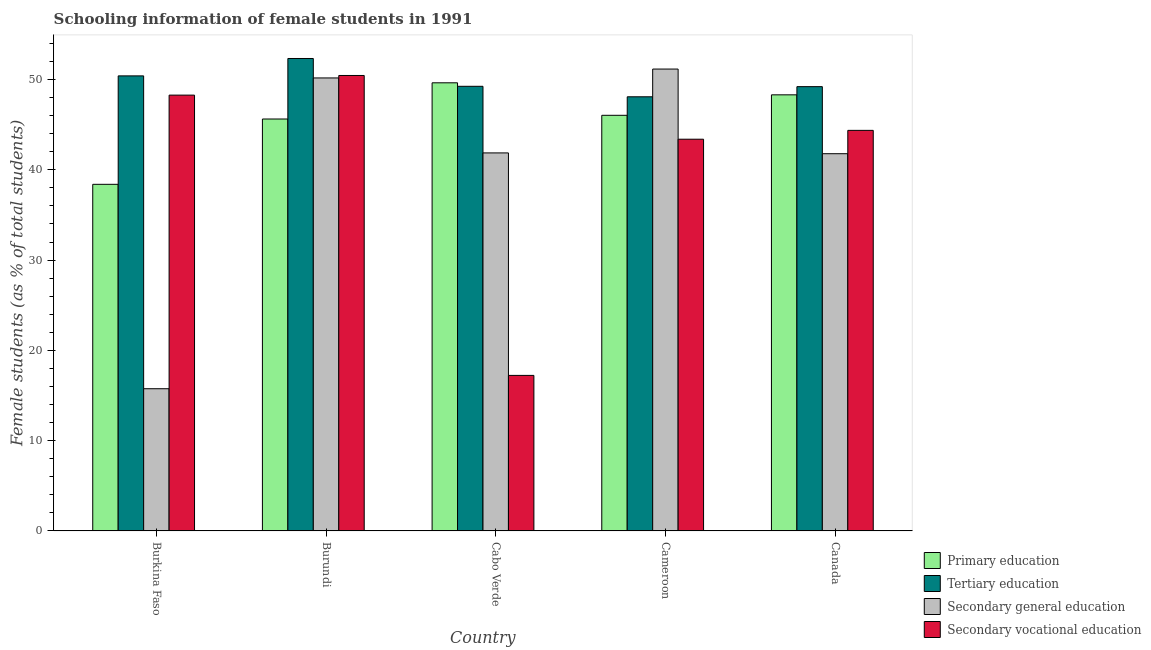How many bars are there on the 4th tick from the right?
Your answer should be very brief. 4. What is the label of the 1st group of bars from the left?
Keep it short and to the point. Burkina Faso. In how many cases, is the number of bars for a given country not equal to the number of legend labels?
Your response must be concise. 0. What is the percentage of female students in primary education in Cabo Verde?
Offer a very short reply. 49.63. Across all countries, what is the maximum percentage of female students in secondary education?
Make the answer very short. 51.16. Across all countries, what is the minimum percentage of female students in secondary vocational education?
Provide a succinct answer. 17.23. In which country was the percentage of female students in tertiary education maximum?
Provide a short and direct response. Burundi. In which country was the percentage of female students in tertiary education minimum?
Offer a very short reply. Cameroon. What is the total percentage of female students in secondary education in the graph?
Your answer should be compact. 200.73. What is the difference between the percentage of female students in secondary vocational education in Burundi and that in Cabo Verde?
Keep it short and to the point. 33.22. What is the difference between the percentage of female students in secondary education in Burundi and the percentage of female students in secondary vocational education in Cabo Verde?
Offer a terse response. 32.94. What is the average percentage of female students in tertiary education per country?
Offer a very short reply. 49.85. What is the difference between the percentage of female students in secondary education and percentage of female students in tertiary education in Burkina Faso?
Your answer should be compact. -34.65. In how many countries, is the percentage of female students in secondary education greater than 10 %?
Offer a very short reply. 5. What is the ratio of the percentage of female students in primary education in Burkina Faso to that in Canada?
Your answer should be very brief. 0.79. Is the percentage of female students in secondary education in Burkina Faso less than that in Canada?
Your answer should be compact. Yes. What is the difference between the highest and the second highest percentage of female students in secondary education?
Give a very brief answer. 0.98. What is the difference between the highest and the lowest percentage of female students in secondary education?
Your response must be concise. 35.41. Is the sum of the percentage of female students in secondary vocational education in Burkina Faso and Cameroon greater than the maximum percentage of female students in secondary education across all countries?
Your answer should be compact. Yes. What does the 4th bar from the left in Cabo Verde represents?
Give a very brief answer. Secondary vocational education. Is it the case that in every country, the sum of the percentage of female students in primary education and percentage of female students in tertiary education is greater than the percentage of female students in secondary education?
Provide a short and direct response. Yes. How many countries are there in the graph?
Your response must be concise. 5. What is the difference between two consecutive major ticks on the Y-axis?
Provide a short and direct response. 10. Are the values on the major ticks of Y-axis written in scientific E-notation?
Your answer should be compact. No. Does the graph contain grids?
Offer a terse response. No. Where does the legend appear in the graph?
Ensure brevity in your answer.  Bottom right. How are the legend labels stacked?
Your answer should be compact. Vertical. What is the title of the graph?
Give a very brief answer. Schooling information of female students in 1991. What is the label or title of the Y-axis?
Your response must be concise. Female students (as % of total students). What is the Female students (as % of total students) in Primary education in Burkina Faso?
Your answer should be compact. 38.39. What is the Female students (as % of total students) of Tertiary education in Burkina Faso?
Keep it short and to the point. 50.4. What is the Female students (as % of total students) of Secondary general education in Burkina Faso?
Provide a succinct answer. 15.75. What is the Female students (as % of total students) in Secondary vocational education in Burkina Faso?
Make the answer very short. 48.27. What is the Female students (as % of total students) of Primary education in Burundi?
Keep it short and to the point. 45.62. What is the Female students (as % of total students) in Tertiary education in Burundi?
Offer a terse response. 52.33. What is the Female students (as % of total students) in Secondary general education in Burundi?
Provide a short and direct response. 50.17. What is the Female students (as % of total students) in Secondary vocational education in Burundi?
Give a very brief answer. 50.45. What is the Female students (as % of total students) in Primary education in Cabo Verde?
Your answer should be very brief. 49.63. What is the Female students (as % of total students) in Tertiary education in Cabo Verde?
Make the answer very short. 49.25. What is the Female students (as % of total students) of Secondary general education in Cabo Verde?
Provide a succinct answer. 41.87. What is the Female students (as % of total students) of Secondary vocational education in Cabo Verde?
Offer a very short reply. 17.23. What is the Female students (as % of total students) in Primary education in Cameroon?
Your answer should be compact. 46.03. What is the Female students (as % of total students) in Tertiary education in Cameroon?
Provide a succinct answer. 48.09. What is the Female students (as % of total students) of Secondary general education in Cameroon?
Give a very brief answer. 51.16. What is the Female students (as % of total students) of Secondary vocational education in Cameroon?
Make the answer very short. 43.39. What is the Female students (as % of total students) of Primary education in Canada?
Make the answer very short. 48.3. What is the Female students (as % of total students) in Tertiary education in Canada?
Make the answer very short. 49.21. What is the Female students (as % of total students) in Secondary general education in Canada?
Keep it short and to the point. 41.78. What is the Female students (as % of total students) of Secondary vocational education in Canada?
Provide a short and direct response. 44.37. Across all countries, what is the maximum Female students (as % of total students) of Primary education?
Provide a succinct answer. 49.63. Across all countries, what is the maximum Female students (as % of total students) of Tertiary education?
Make the answer very short. 52.33. Across all countries, what is the maximum Female students (as % of total students) in Secondary general education?
Keep it short and to the point. 51.16. Across all countries, what is the maximum Female students (as % of total students) of Secondary vocational education?
Make the answer very short. 50.45. Across all countries, what is the minimum Female students (as % of total students) in Primary education?
Provide a short and direct response. 38.39. Across all countries, what is the minimum Female students (as % of total students) of Tertiary education?
Your response must be concise. 48.09. Across all countries, what is the minimum Female students (as % of total students) in Secondary general education?
Your response must be concise. 15.75. Across all countries, what is the minimum Female students (as % of total students) of Secondary vocational education?
Give a very brief answer. 17.23. What is the total Female students (as % of total students) in Primary education in the graph?
Your answer should be compact. 227.99. What is the total Female students (as % of total students) in Tertiary education in the graph?
Your response must be concise. 249.27. What is the total Female students (as % of total students) in Secondary general education in the graph?
Offer a terse response. 200.73. What is the total Female students (as % of total students) in Secondary vocational education in the graph?
Ensure brevity in your answer.  203.7. What is the difference between the Female students (as % of total students) in Primary education in Burkina Faso and that in Burundi?
Your response must be concise. -7.23. What is the difference between the Female students (as % of total students) in Tertiary education in Burkina Faso and that in Burundi?
Your answer should be compact. -1.93. What is the difference between the Female students (as % of total students) in Secondary general education in Burkina Faso and that in Burundi?
Your response must be concise. -34.42. What is the difference between the Female students (as % of total students) of Secondary vocational education in Burkina Faso and that in Burundi?
Ensure brevity in your answer.  -2.18. What is the difference between the Female students (as % of total students) of Primary education in Burkina Faso and that in Cabo Verde?
Your response must be concise. -11.24. What is the difference between the Female students (as % of total students) of Tertiary education in Burkina Faso and that in Cabo Verde?
Provide a short and direct response. 1.15. What is the difference between the Female students (as % of total students) of Secondary general education in Burkina Faso and that in Cabo Verde?
Offer a terse response. -26.12. What is the difference between the Female students (as % of total students) in Secondary vocational education in Burkina Faso and that in Cabo Verde?
Your response must be concise. 31.04. What is the difference between the Female students (as % of total students) of Primary education in Burkina Faso and that in Cameroon?
Give a very brief answer. -7.64. What is the difference between the Female students (as % of total students) of Tertiary education in Burkina Faso and that in Cameroon?
Offer a terse response. 2.32. What is the difference between the Female students (as % of total students) in Secondary general education in Burkina Faso and that in Cameroon?
Your response must be concise. -35.41. What is the difference between the Female students (as % of total students) in Secondary vocational education in Burkina Faso and that in Cameroon?
Give a very brief answer. 4.88. What is the difference between the Female students (as % of total students) of Primary education in Burkina Faso and that in Canada?
Give a very brief answer. -9.91. What is the difference between the Female students (as % of total students) of Tertiary education in Burkina Faso and that in Canada?
Offer a terse response. 1.19. What is the difference between the Female students (as % of total students) of Secondary general education in Burkina Faso and that in Canada?
Your answer should be compact. -26.03. What is the difference between the Female students (as % of total students) of Secondary vocational education in Burkina Faso and that in Canada?
Offer a very short reply. 3.9. What is the difference between the Female students (as % of total students) in Primary education in Burundi and that in Cabo Verde?
Keep it short and to the point. -4.01. What is the difference between the Female students (as % of total students) of Tertiary education in Burundi and that in Cabo Verde?
Provide a short and direct response. 3.08. What is the difference between the Female students (as % of total students) of Secondary general education in Burundi and that in Cabo Verde?
Ensure brevity in your answer.  8.3. What is the difference between the Female students (as % of total students) of Secondary vocational education in Burundi and that in Cabo Verde?
Ensure brevity in your answer.  33.22. What is the difference between the Female students (as % of total students) of Primary education in Burundi and that in Cameroon?
Give a very brief answer. -0.41. What is the difference between the Female students (as % of total students) in Tertiary education in Burundi and that in Cameroon?
Give a very brief answer. 4.24. What is the difference between the Female students (as % of total students) in Secondary general education in Burundi and that in Cameroon?
Provide a succinct answer. -0.98. What is the difference between the Female students (as % of total students) of Secondary vocational education in Burundi and that in Cameroon?
Offer a very short reply. 7.06. What is the difference between the Female students (as % of total students) in Primary education in Burundi and that in Canada?
Offer a very short reply. -2.68. What is the difference between the Female students (as % of total students) in Tertiary education in Burundi and that in Canada?
Your answer should be compact. 3.12. What is the difference between the Female students (as % of total students) of Secondary general education in Burundi and that in Canada?
Your answer should be very brief. 8.39. What is the difference between the Female students (as % of total students) of Secondary vocational education in Burundi and that in Canada?
Give a very brief answer. 6.08. What is the difference between the Female students (as % of total students) in Primary education in Cabo Verde and that in Cameroon?
Your answer should be very brief. 3.6. What is the difference between the Female students (as % of total students) of Tertiary education in Cabo Verde and that in Cameroon?
Your answer should be very brief. 1.16. What is the difference between the Female students (as % of total students) of Secondary general education in Cabo Verde and that in Cameroon?
Provide a short and direct response. -9.29. What is the difference between the Female students (as % of total students) in Secondary vocational education in Cabo Verde and that in Cameroon?
Your response must be concise. -26.16. What is the difference between the Female students (as % of total students) in Primary education in Cabo Verde and that in Canada?
Offer a terse response. 1.33. What is the difference between the Female students (as % of total students) in Tertiary education in Cabo Verde and that in Canada?
Your answer should be very brief. 0.04. What is the difference between the Female students (as % of total students) in Secondary general education in Cabo Verde and that in Canada?
Offer a terse response. 0.09. What is the difference between the Female students (as % of total students) of Secondary vocational education in Cabo Verde and that in Canada?
Offer a very short reply. -27.14. What is the difference between the Female students (as % of total students) in Primary education in Cameroon and that in Canada?
Provide a short and direct response. -2.27. What is the difference between the Female students (as % of total students) in Tertiary education in Cameroon and that in Canada?
Offer a terse response. -1.12. What is the difference between the Female students (as % of total students) of Secondary general education in Cameroon and that in Canada?
Provide a succinct answer. 9.38. What is the difference between the Female students (as % of total students) in Secondary vocational education in Cameroon and that in Canada?
Your response must be concise. -0.98. What is the difference between the Female students (as % of total students) in Primary education in Burkina Faso and the Female students (as % of total students) in Tertiary education in Burundi?
Your answer should be compact. -13.94. What is the difference between the Female students (as % of total students) of Primary education in Burkina Faso and the Female students (as % of total students) of Secondary general education in Burundi?
Your answer should be compact. -11.78. What is the difference between the Female students (as % of total students) of Primary education in Burkina Faso and the Female students (as % of total students) of Secondary vocational education in Burundi?
Your answer should be compact. -12.05. What is the difference between the Female students (as % of total students) of Tertiary education in Burkina Faso and the Female students (as % of total students) of Secondary general education in Burundi?
Offer a very short reply. 0.23. What is the difference between the Female students (as % of total students) in Tertiary education in Burkina Faso and the Female students (as % of total students) in Secondary vocational education in Burundi?
Give a very brief answer. -0.04. What is the difference between the Female students (as % of total students) of Secondary general education in Burkina Faso and the Female students (as % of total students) of Secondary vocational education in Burundi?
Your response must be concise. -34.7. What is the difference between the Female students (as % of total students) in Primary education in Burkina Faso and the Female students (as % of total students) in Tertiary education in Cabo Verde?
Your response must be concise. -10.86. What is the difference between the Female students (as % of total students) of Primary education in Burkina Faso and the Female students (as % of total students) of Secondary general education in Cabo Verde?
Your response must be concise. -3.48. What is the difference between the Female students (as % of total students) in Primary education in Burkina Faso and the Female students (as % of total students) in Secondary vocational education in Cabo Verde?
Ensure brevity in your answer.  21.16. What is the difference between the Female students (as % of total students) in Tertiary education in Burkina Faso and the Female students (as % of total students) in Secondary general education in Cabo Verde?
Give a very brief answer. 8.53. What is the difference between the Female students (as % of total students) in Tertiary education in Burkina Faso and the Female students (as % of total students) in Secondary vocational education in Cabo Verde?
Provide a succinct answer. 33.17. What is the difference between the Female students (as % of total students) of Secondary general education in Burkina Faso and the Female students (as % of total students) of Secondary vocational education in Cabo Verde?
Your answer should be very brief. -1.48. What is the difference between the Female students (as % of total students) in Primary education in Burkina Faso and the Female students (as % of total students) in Tertiary education in Cameroon?
Your response must be concise. -9.69. What is the difference between the Female students (as % of total students) of Primary education in Burkina Faso and the Female students (as % of total students) of Secondary general education in Cameroon?
Your answer should be very brief. -12.76. What is the difference between the Female students (as % of total students) in Primary education in Burkina Faso and the Female students (as % of total students) in Secondary vocational education in Cameroon?
Offer a very short reply. -5. What is the difference between the Female students (as % of total students) of Tertiary education in Burkina Faso and the Female students (as % of total students) of Secondary general education in Cameroon?
Keep it short and to the point. -0.76. What is the difference between the Female students (as % of total students) in Tertiary education in Burkina Faso and the Female students (as % of total students) in Secondary vocational education in Cameroon?
Keep it short and to the point. 7.01. What is the difference between the Female students (as % of total students) in Secondary general education in Burkina Faso and the Female students (as % of total students) in Secondary vocational education in Cameroon?
Offer a very short reply. -27.64. What is the difference between the Female students (as % of total students) of Primary education in Burkina Faso and the Female students (as % of total students) of Tertiary education in Canada?
Your answer should be compact. -10.82. What is the difference between the Female students (as % of total students) in Primary education in Burkina Faso and the Female students (as % of total students) in Secondary general education in Canada?
Your answer should be very brief. -3.39. What is the difference between the Female students (as % of total students) of Primary education in Burkina Faso and the Female students (as % of total students) of Secondary vocational education in Canada?
Ensure brevity in your answer.  -5.97. What is the difference between the Female students (as % of total students) in Tertiary education in Burkina Faso and the Female students (as % of total students) in Secondary general education in Canada?
Your answer should be very brief. 8.62. What is the difference between the Female students (as % of total students) of Tertiary education in Burkina Faso and the Female students (as % of total students) of Secondary vocational education in Canada?
Ensure brevity in your answer.  6.04. What is the difference between the Female students (as % of total students) in Secondary general education in Burkina Faso and the Female students (as % of total students) in Secondary vocational education in Canada?
Your answer should be very brief. -28.62. What is the difference between the Female students (as % of total students) in Primary education in Burundi and the Female students (as % of total students) in Tertiary education in Cabo Verde?
Make the answer very short. -3.62. What is the difference between the Female students (as % of total students) in Primary education in Burundi and the Female students (as % of total students) in Secondary general education in Cabo Verde?
Give a very brief answer. 3.76. What is the difference between the Female students (as % of total students) of Primary education in Burundi and the Female students (as % of total students) of Secondary vocational education in Cabo Verde?
Your response must be concise. 28.4. What is the difference between the Female students (as % of total students) in Tertiary education in Burundi and the Female students (as % of total students) in Secondary general education in Cabo Verde?
Your answer should be compact. 10.46. What is the difference between the Female students (as % of total students) of Tertiary education in Burundi and the Female students (as % of total students) of Secondary vocational education in Cabo Verde?
Your response must be concise. 35.1. What is the difference between the Female students (as % of total students) in Secondary general education in Burundi and the Female students (as % of total students) in Secondary vocational education in Cabo Verde?
Offer a terse response. 32.95. What is the difference between the Female students (as % of total students) of Primary education in Burundi and the Female students (as % of total students) of Tertiary education in Cameroon?
Your answer should be very brief. -2.46. What is the difference between the Female students (as % of total students) of Primary education in Burundi and the Female students (as % of total students) of Secondary general education in Cameroon?
Your answer should be compact. -5.53. What is the difference between the Female students (as % of total students) of Primary education in Burundi and the Female students (as % of total students) of Secondary vocational education in Cameroon?
Provide a short and direct response. 2.24. What is the difference between the Female students (as % of total students) of Tertiary education in Burundi and the Female students (as % of total students) of Secondary general education in Cameroon?
Provide a short and direct response. 1.17. What is the difference between the Female students (as % of total students) of Tertiary education in Burundi and the Female students (as % of total students) of Secondary vocational education in Cameroon?
Provide a short and direct response. 8.94. What is the difference between the Female students (as % of total students) in Secondary general education in Burundi and the Female students (as % of total students) in Secondary vocational education in Cameroon?
Provide a succinct answer. 6.79. What is the difference between the Female students (as % of total students) in Primary education in Burundi and the Female students (as % of total students) in Tertiary education in Canada?
Your answer should be compact. -3.58. What is the difference between the Female students (as % of total students) in Primary education in Burundi and the Female students (as % of total students) in Secondary general education in Canada?
Ensure brevity in your answer.  3.84. What is the difference between the Female students (as % of total students) in Primary education in Burundi and the Female students (as % of total students) in Secondary vocational education in Canada?
Offer a very short reply. 1.26. What is the difference between the Female students (as % of total students) of Tertiary education in Burundi and the Female students (as % of total students) of Secondary general education in Canada?
Keep it short and to the point. 10.55. What is the difference between the Female students (as % of total students) of Tertiary education in Burundi and the Female students (as % of total students) of Secondary vocational education in Canada?
Make the answer very short. 7.96. What is the difference between the Female students (as % of total students) of Secondary general education in Burundi and the Female students (as % of total students) of Secondary vocational education in Canada?
Your answer should be compact. 5.81. What is the difference between the Female students (as % of total students) of Primary education in Cabo Verde and the Female students (as % of total students) of Tertiary education in Cameroon?
Give a very brief answer. 1.55. What is the difference between the Female students (as % of total students) in Primary education in Cabo Verde and the Female students (as % of total students) in Secondary general education in Cameroon?
Your answer should be compact. -1.52. What is the difference between the Female students (as % of total students) of Primary education in Cabo Verde and the Female students (as % of total students) of Secondary vocational education in Cameroon?
Ensure brevity in your answer.  6.25. What is the difference between the Female students (as % of total students) in Tertiary education in Cabo Verde and the Female students (as % of total students) in Secondary general education in Cameroon?
Offer a very short reply. -1.91. What is the difference between the Female students (as % of total students) of Tertiary education in Cabo Verde and the Female students (as % of total students) of Secondary vocational education in Cameroon?
Offer a very short reply. 5.86. What is the difference between the Female students (as % of total students) in Secondary general education in Cabo Verde and the Female students (as % of total students) in Secondary vocational education in Cameroon?
Offer a terse response. -1.52. What is the difference between the Female students (as % of total students) in Primary education in Cabo Verde and the Female students (as % of total students) in Tertiary education in Canada?
Offer a very short reply. 0.43. What is the difference between the Female students (as % of total students) in Primary education in Cabo Verde and the Female students (as % of total students) in Secondary general education in Canada?
Your answer should be compact. 7.85. What is the difference between the Female students (as % of total students) in Primary education in Cabo Verde and the Female students (as % of total students) in Secondary vocational education in Canada?
Your response must be concise. 5.27. What is the difference between the Female students (as % of total students) of Tertiary education in Cabo Verde and the Female students (as % of total students) of Secondary general education in Canada?
Your answer should be very brief. 7.47. What is the difference between the Female students (as % of total students) of Tertiary education in Cabo Verde and the Female students (as % of total students) of Secondary vocational education in Canada?
Your answer should be very brief. 4.88. What is the difference between the Female students (as % of total students) in Secondary general education in Cabo Verde and the Female students (as % of total students) in Secondary vocational education in Canada?
Your answer should be very brief. -2.5. What is the difference between the Female students (as % of total students) of Primary education in Cameroon and the Female students (as % of total students) of Tertiary education in Canada?
Your response must be concise. -3.17. What is the difference between the Female students (as % of total students) of Primary education in Cameroon and the Female students (as % of total students) of Secondary general education in Canada?
Your answer should be compact. 4.25. What is the difference between the Female students (as % of total students) in Primary education in Cameroon and the Female students (as % of total students) in Secondary vocational education in Canada?
Your answer should be very brief. 1.67. What is the difference between the Female students (as % of total students) in Tertiary education in Cameroon and the Female students (as % of total students) in Secondary general education in Canada?
Give a very brief answer. 6.3. What is the difference between the Female students (as % of total students) of Tertiary education in Cameroon and the Female students (as % of total students) of Secondary vocational education in Canada?
Keep it short and to the point. 3.72. What is the difference between the Female students (as % of total students) in Secondary general education in Cameroon and the Female students (as % of total students) in Secondary vocational education in Canada?
Ensure brevity in your answer.  6.79. What is the average Female students (as % of total students) of Primary education per country?
Keep it short and to the point. 45.6. What is the average Female students (as % of total students) in Tertiary education per country?
Make the answer very short. 49.85. What is the average Female students (as % of total students) of Secondary general education per country?
Offer a very short reply. 40.15. What is the average Female students (as % of total students) of Secondary vocational education per country?
Make the answer very short. 40.74. What is the difference between the Female students (as % of total students) in Primary education and Female students (as % of total students) in Tertiary education in Burkina Faso?
Your response must be concise. -12.01. What is the difference between the Female students (as % of total students) of Primary education and Female students (as % of total students) of Secondary general education in Burkina Faso?
Keep it short and to the point. 22.64. What is the difference between the Female students (as % of total students) of Primary education and Female students (as % of total students) of Secondary vocational education in Burkina Faso?
Ensure brevity in your answer.  -9.88. What is the difference between the Female students (as % of total students) in Tertiary education and Female students (as % of total students) in Secondary general education in Burkina Faso?
Offer a terse response. 34.65. What is the difference between the Female students (as % of total students) in Tertiary education and Female students (as % of total students) in Secondary vocational education in Burkina Faso?
Your answer should be compact. 2.13. What is the difference between the Female students (as % of total students) of Secondary general education and Female students (as % of total students) of Secondary vocational education in Burkina Faso?
Ensure brevity in your answer.  -32.52. What is the difference between the Female students (as % of total students) of Primary education and Female students (as % of total students) of Tertiary education in Burundi?
Your answer should be compact. -6.7. What is the difference between the Female students (as % of total students) in Primary education and Female students (as % of total students) in Secondary general education in Burundi?
Provide a short and direct response. -4.55. What is the difference between the Female students (as % of total students) in Primary education and Female students (as % of total students) in Secondary vocational education in Burundi?
Make the answer very short. -4.82. What is the difference between the Female students (as % of total students) of Tertiary education and Female students (as % of total students) of Secondary general education in Burundi?
Ensure brevity in your answer.  2.15. What is the difference between the Female students (as % of total students) in Tertiary education and Female students (as % of total students) in Secondary vocational education in Burundi?
Make the answer very short. 1.88. What is the difference between the Female students (as % of total students) of Secondary general education and Female students (as % of total students) of Secondary vocational education in Burundi?
Make the answer very short. -0.27. What is the difference between the Female students (as % of total students) in Primary education and Female students (as % of total students) in Tertiary education in Cabo Verde?
Provide a short and direct response. 0.39. What is the difference between the Female students (as % of total students) in Primary education and Female students (as % of total students) in Secondary general education in Cabo Verde?
Give a very brief answer. 7.76. What is the difference between the Female students (as % of total students) in Primary education and Female students (as % of total students) in Secondary vocational education in Cabo Verde?
Provide a short and direct response. 32.41. What is the difference between the Female students (as % of total students) in Tertiary education and Female students (as % of total students) in Secondary general education in Cabo Verde?
Ensure brevity in your answer.  7.38. What is the difference between the Female students (as % of total students) of Tertiary education and Female students (as % of total students) of Secondary vocational education in Cabo Verde?
Offer a very short reply. 32.02. What is the difference between the Female students (as % of total students) in Secondary general education and Female students (as % of total students) in Secondary vocational education in Cabo Verde?
Ensure brevity in your answer.  24.64. What is the difference between the Female students (as % of total students) in Primary education and Female students (as % of total students) in Tertiary education in Cameroon?
Provide a short and direct response. -2.05. What is the difference between the Female students (as % of total students) in Primary education and Female students (as % of total students) in Secondary general education in Cameroon?
Your response must be concise. -5.12. What is the difference between the Female students (as % of total students) in Primary education and Female students (as % of total students) in Secondary vocational education in Cameroon?
Provide a succinct answer. 2.65. What is the difference between the Female students (as % of total students) in Tertiary education and Female students (as % of total students) in Secondary general education in Cameroon?
Ensure brevity in your answer.  -3.07. What is the difference between the Female students (as % of total students) in Tertiary education and Female students (as % of total students) in Secondary vocational education in Cameroon?
Offer a terse response. 4.7. What is the difference between the Female students (as % of total students) of Secondary general education and Female students (as % of total students) of Secondary vocational education in Cameroon?
Offer a terse response. 7.77. What is the difference between the Female students (as % of total students) of Primary education and Female students (as % of total students) of Tertiary education in Canada?
Provide a succinct answer. -0.91. What is the difference between the Female students (as % of total students) in Primary education and Female students (as % of total students) in Secondary general education in Canada?
Keep it short and to the point. 6.52. What is the difference between the Female students (as % of total students) in Primary education and Female students (as % of total students) in Secondary vocational education in Canada?
Provide a succinct answer. 3.94. What is the difference between the Female students (as % of total students) in Tertiary education and Female students (as % of total students) in Secondary general education in Canada?
Your answer should be very brief. 7.43. What is the difference between the Female students (as % of total students) of Tertiary education and Female students (as % of total students) of Secondary vocational education in Canada?
Offer a very short reply. 4.84. What is the difference between the Female students (as % of total students) of Secondary general education and Female students (as % of total students) of Secondary vocational education in Canada?
Offer a very short reply. -2.58. What is the ratio of the Female students (as % of total students) of Primary education in Burkina Faso to that in Burundi?
Provide a succinct answer. 0.84. What is the ratio of the Female students (as % of total students) of Tertiary education in Burkina Faso to that in Burundi?
Make the answer very short. 0.96. What is the ratio of the Female students (as % of total students) in Secondary general education in Burkina Faso to that in Burundi?
Make the answer very short. 0.31. What is the ratio of the Female students (as % of total students) of Secondary vocational education in Burkina Faso to that in Burundi?
Provide a succinct answer. 0.96. What is the ratio of the Female students (as % of total students) of Primary education in Burkina Faso to that in Cabo Verde?
Give a very brief answer. 0.77. What is the ratio of the Female students (as % of total students) in Tertiary education in Burkina Faso to that in Cabo Verde?
Your response must be concise. 1.02. What is the ratio of the Female students (as % of total students) of Secondary general education in Burkina Faso to that in Cabo Verde?
Your response must be concise. 0.38. What is the ratio of the Female students (as % of total students) of Secondary vocational education in Burkina Faso to that in Cabo Verde?
Your answer should be compact. 2.8. What is the ratio of the Female students (as % of total students) in Primary education in Burkina Faso to that in Cameroon?
Make the answer very short. 0.83. What is the ratio of the Female students (as % of total students) of Tertiary education in Burkina Faso to that in Cameroon?
Provide a succinct answer. 1.05. What is the ratio of the Female students (as % of total students) of Secondary general education in Burkina Faso to that in Cameroon?
Your answer should be very brief. 0.31. What is the ratio of the Female students (as % of total students) in Secondary vocational education in Burkina Faso to that in Cameroon?
Give a very brief answer. 1.11. What is the ratio of the Female students (as % of total students) in Primary education in Burkina Faso to that in Canada?
Your answer should be compact. 0.79. What is the ratio of the Female students (as % of total students) of Tertiary education in Burkina Faso to that in Canada?
Ensure brevity in your answer.  1.02. What is the ratio of the Female students (as % of total students) in Secondary general education in Burkina Faso to that in Canada?
Your response must be concise. 0.38. What is the ratio of the Female students (as % of total students) of Secondary vocational education in Burkina Faso to that in Canada?
Ensure brevity in your answer.  1.09. What is the ratio of the Female students (as % of total students) in Primary education in Burundi to that in Cabo Verde?
Your answer should be very brief. 0.92. What is the ratio of the Female students (as % of total students) in Tertiary education in Burundi to that in Cabo Verde?
Provide a short and direct response. 1.06. What is the ratio of the Female students (as % of total students) of Secondary general education in Burundi to that in Cabo Verde?
Give a very brief answer. 1.2. What is the ratio of the Female students (as % of total students) of Secondary vocational education in Burundi to that in Cabo Verde?
Your response must be concise. 2.93. What is the ratio of the Female students (as % of total students) in Primary education in Burundi to that in Cameroon?
Ensure brevity in your answer.  0.99. What is the ratio of the Female students (as % of total students) of Tertiary education in Burundi to that in Cameroon?
Give a very brief answer. 1.09. What is the ratio of the Female students (as % of total students) of Secondary general education in Burundi to that in Cameroon?
Your response must be concise. 0.98. What is the ratio of the Female students (as % of total students) of Secondary vocational education in Burundi to that in Cameroon?
Offer a very short reply. 1.16. What is the ratio of the Female students (as % of total students) of Primary education in Burundi to that in Canada?
Your answer should be compact. 0.94. What is the ratio of the Female students (as % of total students) of Tertiary education in Burundi to that in Canada?
Your response must be concise. 1.06. What is the ratio of the Female students (as % of total students) of Secondary general education in Burundi to that in Canada?
Keep it short and to the point. 1.2. What is the ratio of the Female students (as % of total students) of Secondary vocational education in Burundi to that in Canada?
Your answer should be compact. 1.14. What is the ratio of the Female students (as % of total students) in Primary education in Cabo Verde to that in Cameroon?
Provide a succinct answer. 1.08. What is the ratio of the Female students (as % of total students) of Tertiary education in Cabo Verde to that in Cameroon?
Provide a short and direct response. 1.02. What is the ratio of the Female students (as % of total students) in Secondary general education in Cabo Verde to that in Cameroon?
Offer a very short reply. 0.82. What is the ratio of the Female students (as % of total students) of Secondary vocational education in Cabo Verde to that in Cameroon?
Your answer should be very brief. 0.4. What is the ratio of the Female students (as % of total students) in Primary education in Cabo Verde to that in Canada?
Your answer should be very brief. 1.03. What is the ratio of the Female students (as % of total students) of Secondary vocational education in Cabo Verde to that in Canada?
Keep it short and to the point. 0.39. What is the ratio of the Female students (as % of total students) in Primary education in Cameroon to that in Canada?
Make the answer very short. 0.95. What is the ratio of the Female students (as % of total students) in Tertiary education in Cameroon to that in Canada?
Give a very brief answer. 0.98. What is the ratio of the Female students (as % of total students) in Secondary general education in Cameroon to that in Canada?
Provide a short and direct response. 1.22. What is the ratio of the Female students (as % of total students) in Secondary vocational education in Cameroon to that in Canada?
Your response must be concise. 0.98. What is the difference between the highest and the second highest Female students (as % of total students) in Primary education?
Offer a very short reply. 1.33. What is the difference between the highest and the second highest Female students (as % of total students) in Tertiary education?
Provide a succinct answer. 1.93. What is the difference between the highest and the second highest Female students (as % of total students) in Secondary general education?
Ensure brevity in your answer.  0.98. What is the difference between the highest and the second highest Female students (as % of total students) of Secondary vocational education?
Your answer should be very brief. 2.18. What is the difference between the highest and the lowest Female students (as % of total students) in Primary education?
Ensure brevity in your answer.  11.24. What is the difference between the highest and the lowest Female students (as % of total students) of Tertiary education?
Your answer should be compact. 4.24. What is the difference between the highest and the lowest Female students (as % of total students) in Secondary general education?
Offer a very short reply. 35.41. What is the difference between the highest and the lowest Female students (as % of total students) in Secondary vocational education?
Ensure brevity in your answer.  33.22. 